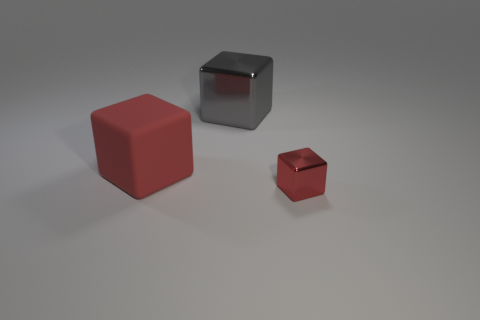There is a large object behind the red cube that is behind the tiny red object; what is it made of?
Make the answer very short. Metal. There is another metallic object that is the same shape as the small shiny object; what size is it?
Give a very brief answer. Large. There is a metal cube that is behind the tiny red metallic block; is its color the same as the small cube?
Offer a terse response. No. Is the number of metal cylinders less than the number of large gray things?
Give a very brief answer. Yes. What number of other objects are the same color as the small metallic block?
Your answer should be compact. 1. Do the red thing that is right of the gray shiny cube and the big gray cube have the same material?
Your response must be concise. Yes. What material is the large block that is behind the large red cube?
Keep it short and to the point. Metal. How big is the thing to the right of the object behind the matte cube?
Provide a short and direct response. Small. Are there any big blue blocks that have the same material as the large gray block?
Make the answer very short. No. What is the shape of the red object behind the metal thing to the right of the big object that is right of the matte cube?
Offer a terse response. Cube. 